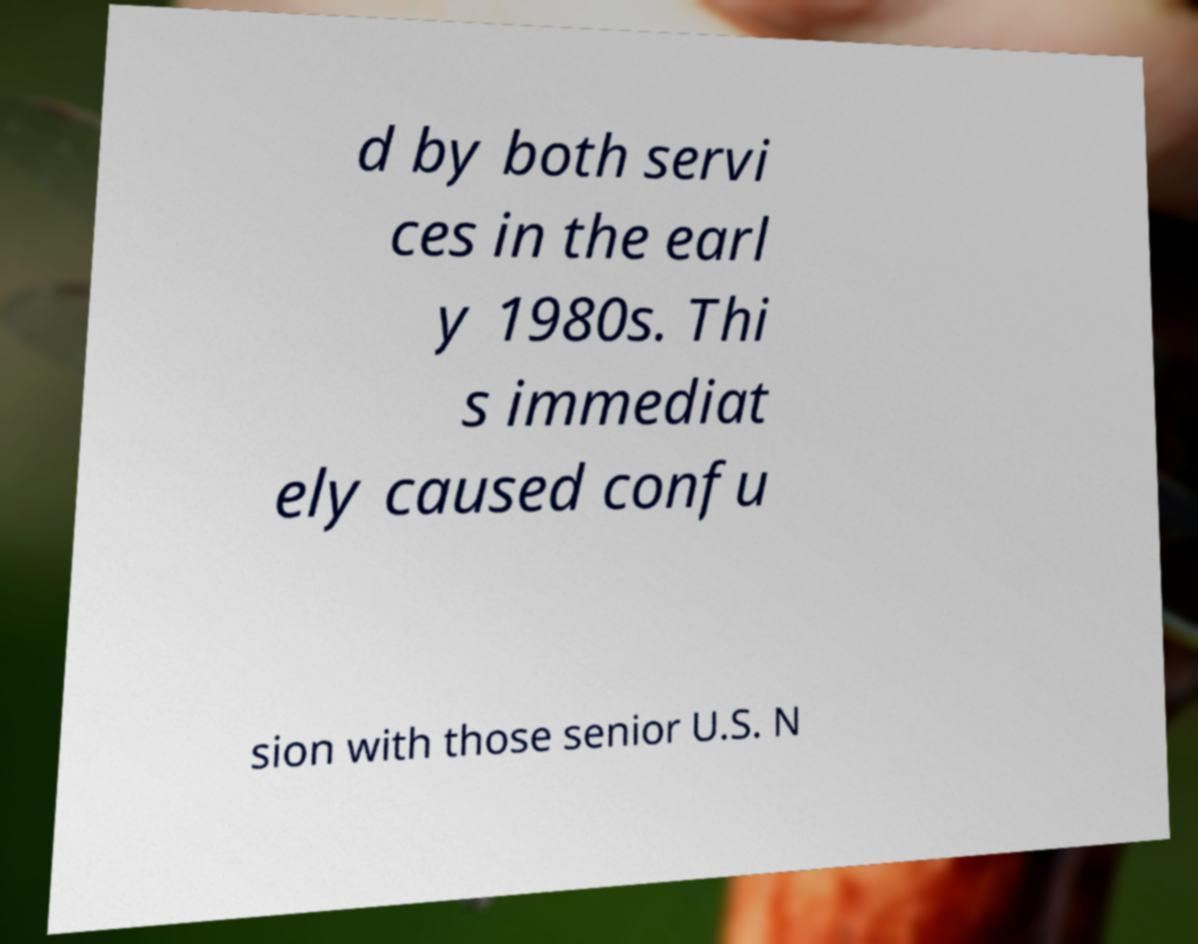Please identify and transcribe the text found in this image. d by both servi ces in the earl y 1980s. Thi s immediat ely caused confu sion with those senior U.S. N 